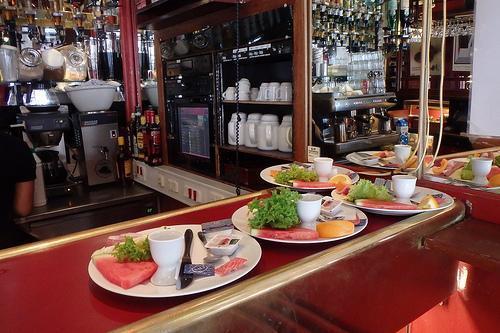How many plates are there?
Give a very brief answer. 5. 